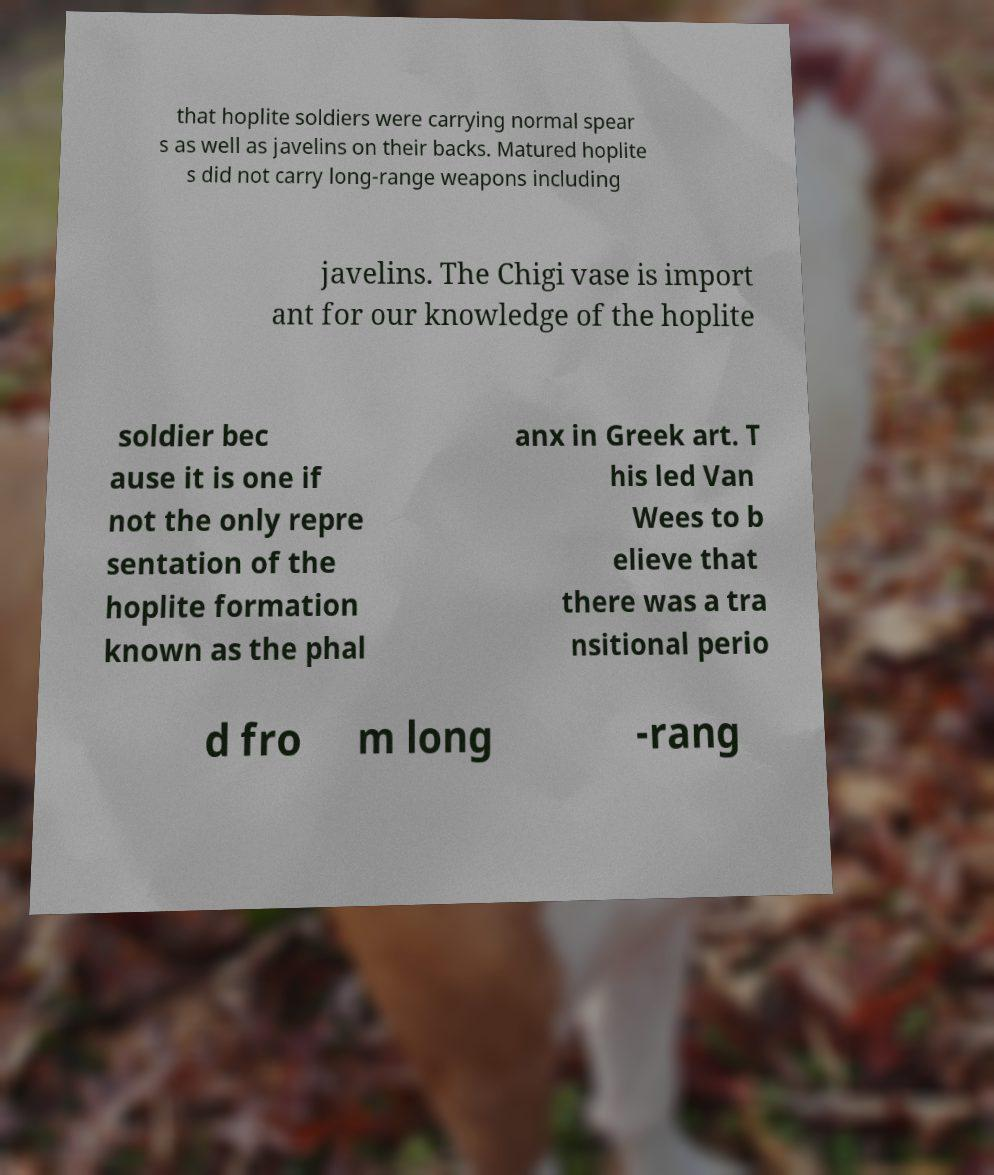There's text embedded in this image that I need extracted. Can you transcribe it verbatim? that hoplite soldiers were carrying normal spear s as well as javelins on their backs. Matured hoplite s did not carry long-range weapons including javelins. The Chigi vase is import ant for our knowledge of the hoplite soldier bec ause it is one if not the only repre sentation of the hoplite formation known as the phal anx in Greek art. T his led Van Wees to b elieve that there was a tra nsitional perio d fro m long -rang 